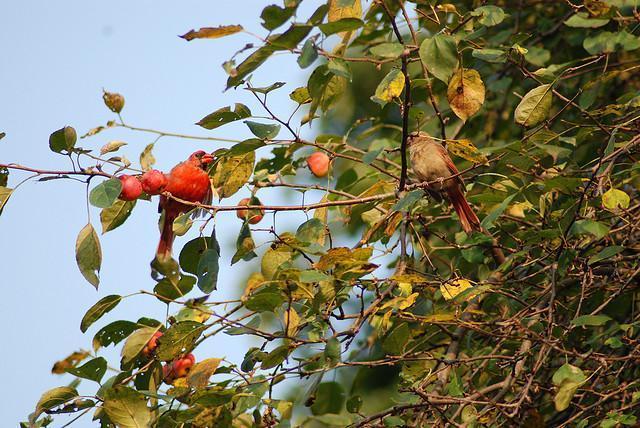How many birds are there?
Give a very brief answer. 2. How many women are there?
Give a very brief answer. 0. 